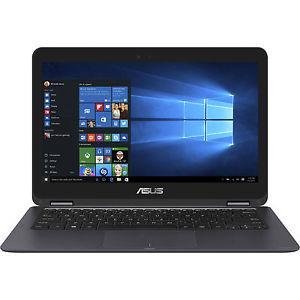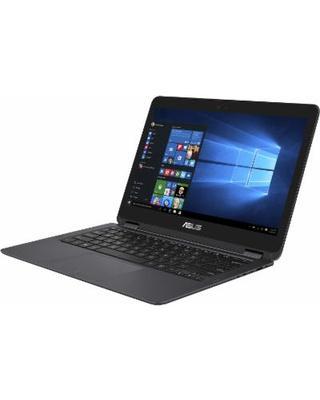The first image is the image on the left, the second image is the image on the right. Analyze the images presented: Is the assertion "The name on the lid and the screen can both be seen." valid? Answer yes or no. No. The first image is the image on the left, the second image is the image on the right. Assess this claim about the two images: "You cannot see the screen of the laptop on the right side of the image.". Correct or not? Answer yes or no. No. 